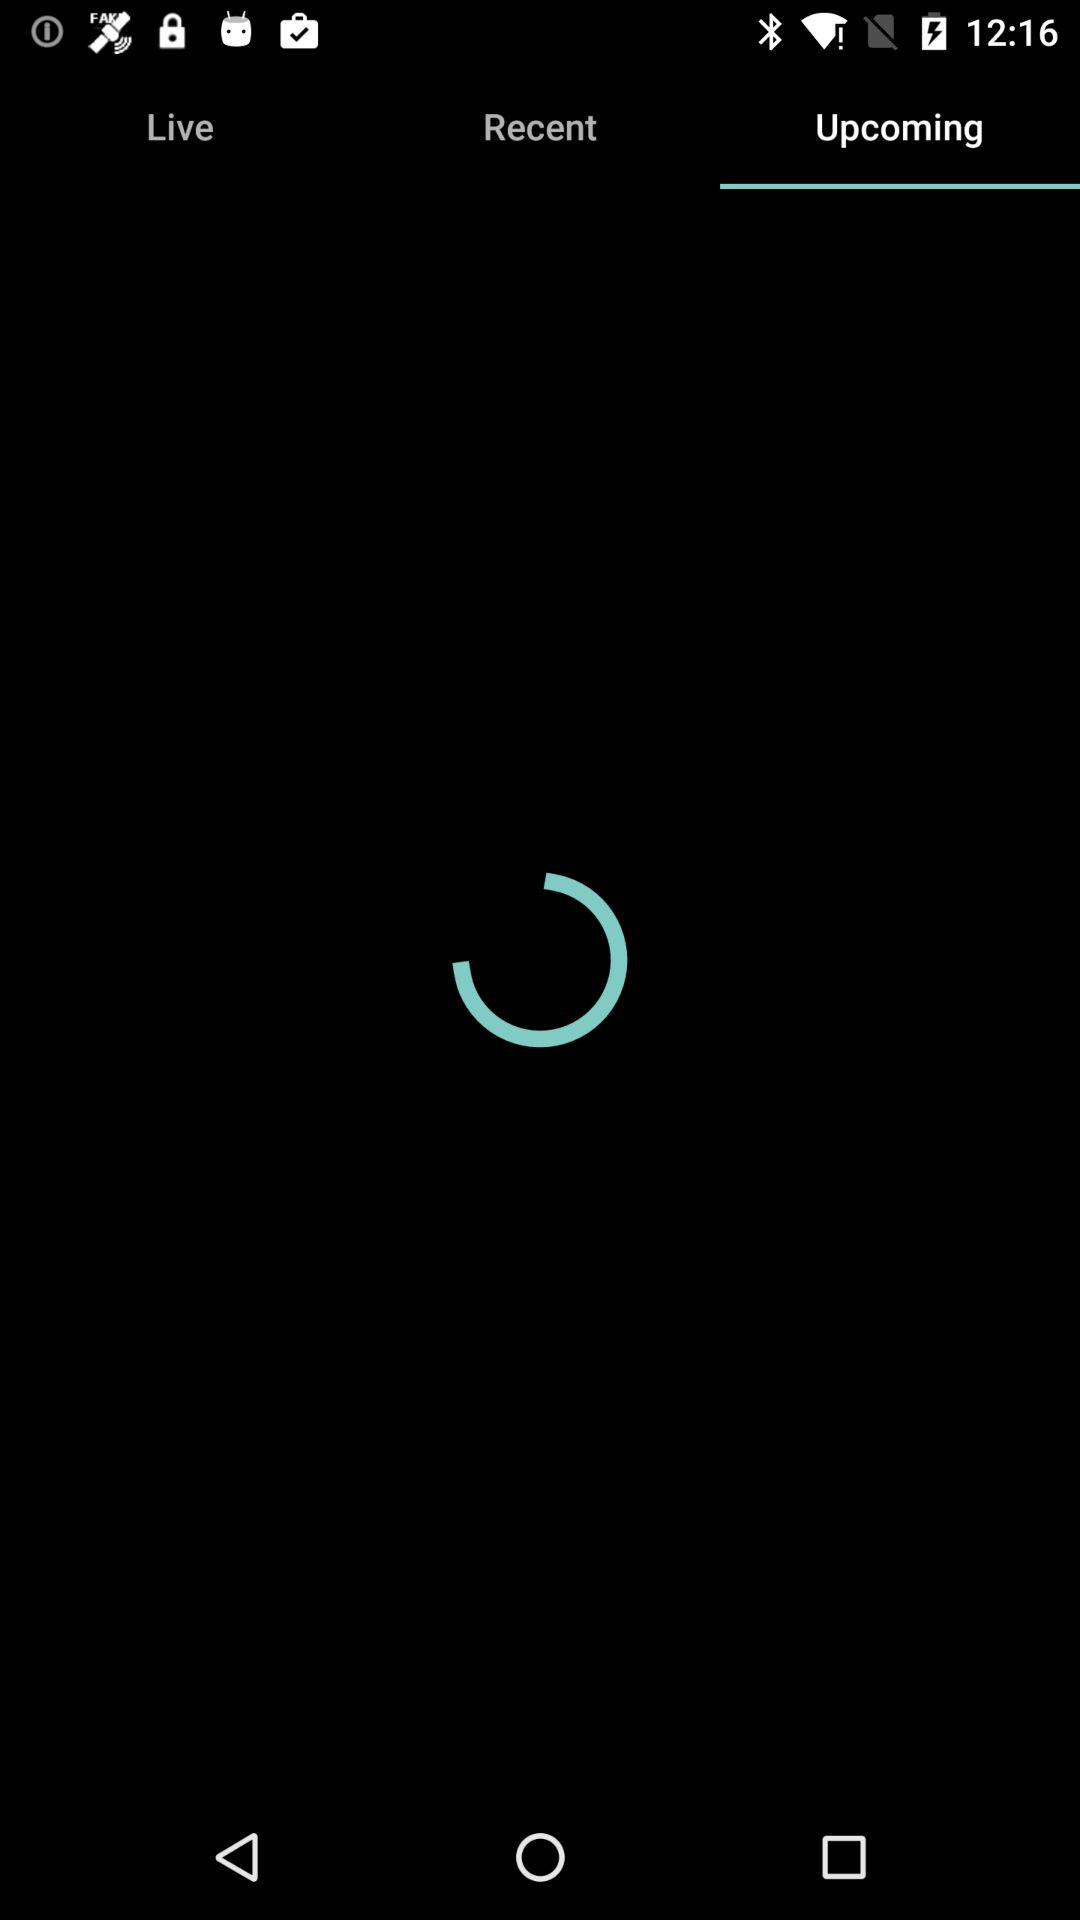Which tab has been selected? The selected tab is "Upcoming". 